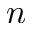<formula> <loc_0><loc_0><loc_500><loc_500>n</formula> 